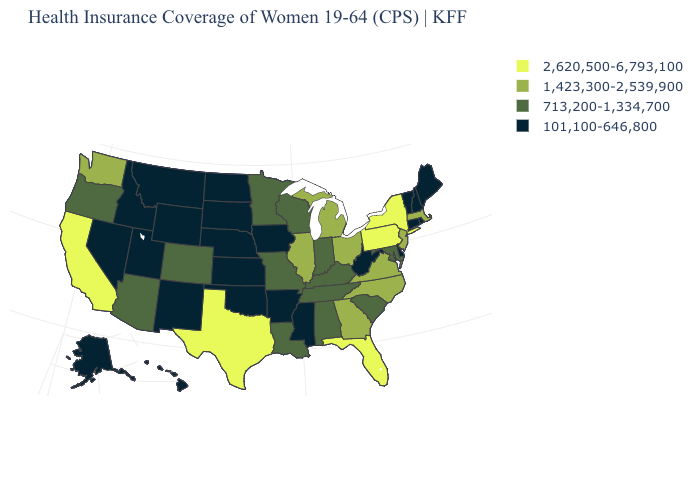What is the value of Nevada?
Concise answer only. 101,100-646,800. Which states have the lowest value in the USA?
Concise answer only. Alaska, Arkansas, Connecticut, Delaware, Hawaii, Idaho, Iowa, Kansas, Maine, Mississippi, Montana, Nebraska, Nevada, New Hampshire, New Mexico, North Dakota, Oklahoma, Rhode Island, South Dakota, Utah, Vermont, West Virginia, Wyoming. Name the states that have a value in the range 101,100-646,800?
Quick response, please. Alaska, Arkansas, Connecticut, Delaware, Hawaii, Idaho, Iowa, Kansas, Maine, Mississippi, Montana, Nebraska, Nevada, New Hampshire, New Mexico, North Dakota, Oklahoma, Rhode Island, South Dakota, Utah, Vermont, West Virginia, Wyoming. Which states have the highest value in the USA?
Quick response, please. California, Florida, New York, Pennsylvania, Texas. What is the lowest value in the USA?
Be succinct. 101,100-646,800. Name the states that have a value in the range 1,423,300-2,539,900?
Answer briefly. Georgia, Illinois, Massachusetts, Michigan, New Jersey, North Carolina, Ohio, Virginia, Washington. Does Texas have the lowest value in the South?
Be succinct. No. Does the map have missing data?
Quick response, please. No. Name the states that have a value in the range 101,100-646,800?
Short answer required. Alaska, Arkansas, Connecticut, Delaware, Hawaii, Idaho, Iowa, Kansas, Maine, Mississippi, Montana, Nebraska, Nevada, New Hampshire, New Mexico, North Dakota, Oklahoma, Rhode Island, South Dakota, Utah, Vermont, West Virginia, Wyoming. What is the value of Minnesota?
Quick response, please. 713,200-1,334,700. Does Oregon have the same value as New York?
Answer briefly. No. Is the legend a continuous bar?
Be succinct. No. What is the value of Alabama?
Be succinct. 713,200-1,334,700. Among the states that border Tennessee , does Virginia have the highest value?
Short answer required. Yes. 